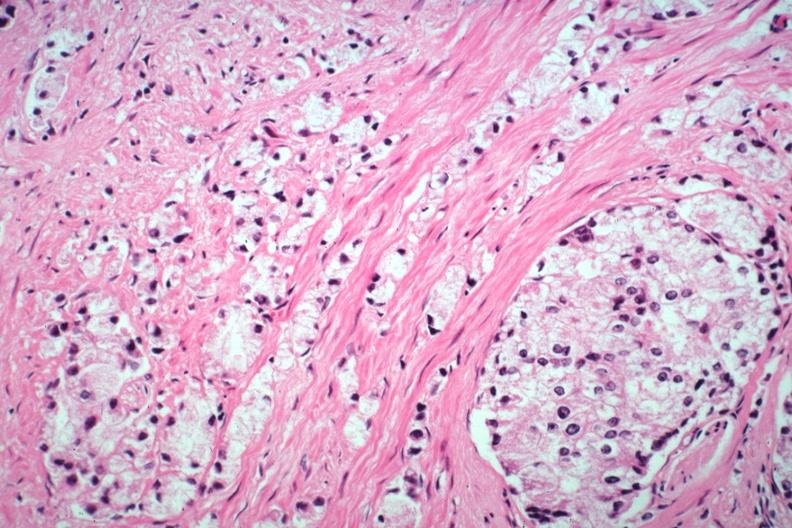does this image show typical infiltrating lesion?
Answer the question using a single word or phrase. Yes 